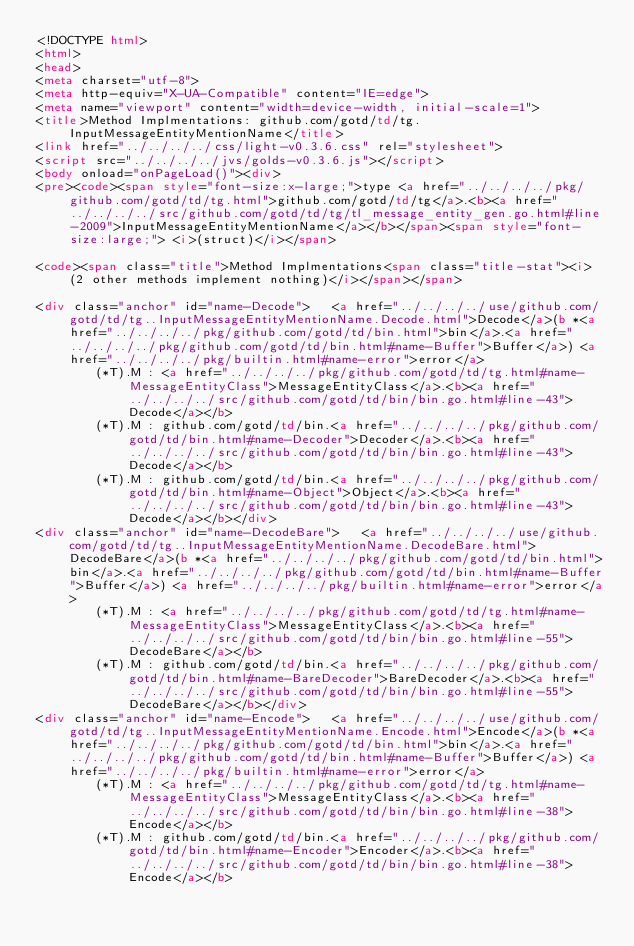<code> <loc_0><loc_0><loc_500><loc_500><_HTML_><!DOCTYPE html>
<html>
<head>
<meta charset="utf-8">
<meta http-equiv="X-UA-Compatible" content="IE=edge">
<meta name="viewport" content="width=device-width, initial-scale=1">
<title>Method Implmentations: github.com/gotd/td/tg.InputMessageEntityMentionName</title>
<link href="../../../../css/light-v0.3.6.css" rel="stylesheet">
<script src="../../../../jvs/golds-v0.3.6.js"></script>
<body onload="onPageLoad()"><div>
<pre><code><span style="font-size:x-large;">type <a href="../../../../pkg/github.com/gotd/td/tg.html">github.com/gotd/td/tg</a>.<b><a href="../../../../src/github.com/gotd/td/tg/tl_message_entity_gen.go.html#line-2009">InputMessageEntityMentionName</a></b></span><span style="font-size:large;"> <i>(struct)</i></span>

<code><span class="title">Method Implmentations<span class="title-stat"><i> (2 other methods implement nothing)</i></span></span>

<div class="anchor" id="name-Decode">	<a href="../../../../use/github.com/gotd/td/tg..InputMessageEntityMentionName.Decode.html">Decode</a>(b *<a href="../../../../pkg/github.com/gotd/td/bin.html">bin</a>.<a href="../../../../pkg/github.com/gotd/td/bin.html#name-Buffer">Buffer</a>) <a href="../../../../pkg/builtin.html#name-error">error</a>
		(*T).M : <a href="../../../../pkg/github.com/gotd/td/tg.html#name-MessageEntityClass">MessageEntityClass</a>.<b><a href="../../../../src/github.com/gotd/td/bin/bin.go.html#line-43">Decode</a></b>
		(*T).M : github.com/gotd/td/bin.<a href="../../../../pkg/github.com/gotd/td/bin.html#name-Decoder">Decoder</a>.<b><a href="../../../../src/github.com/gotd/td/bin/bin.go.html#line-43">Decode</a></b>
		(*T).M : github.com/gotd/td/bin.<a href="../../../../pkg/github.com/gotd/td/bin.html#name-Object">Object</a>.<b><a href="../../../../src/github.com/gotd/td/bin/bin.go.html#line-43">Decode</a></b></div>
<div class="anchor" id="name-DecodeBare">	<a href="../../../../use/github.com/gotd/td/tg..InputMessageEntityMentionName.DecodeBare.html">DecodeBare</a>(b *<a href="../../../../pkg/github.com/gotd/td/bin.html">bin</a>.<a href="../../../../pkg/github.com/gotd/td/bin.html#name-Buffer">Buffer</a>) <a href="../../../../pkg/builtin.html#name-error">error</a>
		(*T).M : <a href="../../../../pkg/github.com/gotd/td/tg.html#name-MessageEntityClass">MessageEntityClass</a>.<b><a href="../../../../src/github.com/gotd/td/bin/bin.go.html#line-55">DecodeBare</a></b>
		(*T).M : github.com/gotd/td/bin.<a href="../../../../pkg/github.com/gotd/td/bin.html#name-BareDecoder">BareDecoder</a>.<b><a href="../../../../src/github.com/gotd/td/bin/bin.go.html#line-55">DecodeBare</a></b></div>
<div class="anchor" id="name-Encode">	<a href="../../../../use/github.com/gotd/td/tg..InputMessageEntityMentionName.Encode.html">Encode</a>(b *<a href="../../../../pkg/github.com/gotd/td/bin.html">bin</a>.<a href="../../../../pkg/github.com/gotd/td/bin.html#name-Buffer">Buffer</a>) <a href="../../../../pkg/builtin.html#name-error">error</a>
		(*T).M : <a href="../../../../pkg/github.com/gotd/td/tg.html#name-MessageEntityClass">MessageEntityClass</a>.<b><a href="../../../../src/github.com/gotd/td/bin/bin.go.html#line-38">Encode</a></b>
		(*T).M : github.com/gotd/td/bin.<a href="../../../../pkg/github.com/gotd/td/bin.html#name-Encoder">Encoder</a>.<b><a href="../../../../src/github.com/gotd/td/bin/bin.go.html#line-38">Encode</a></b></code> 